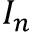<formula> <loc_0><loc_0><loc_500><loc_500>I _ { n }</formula> 